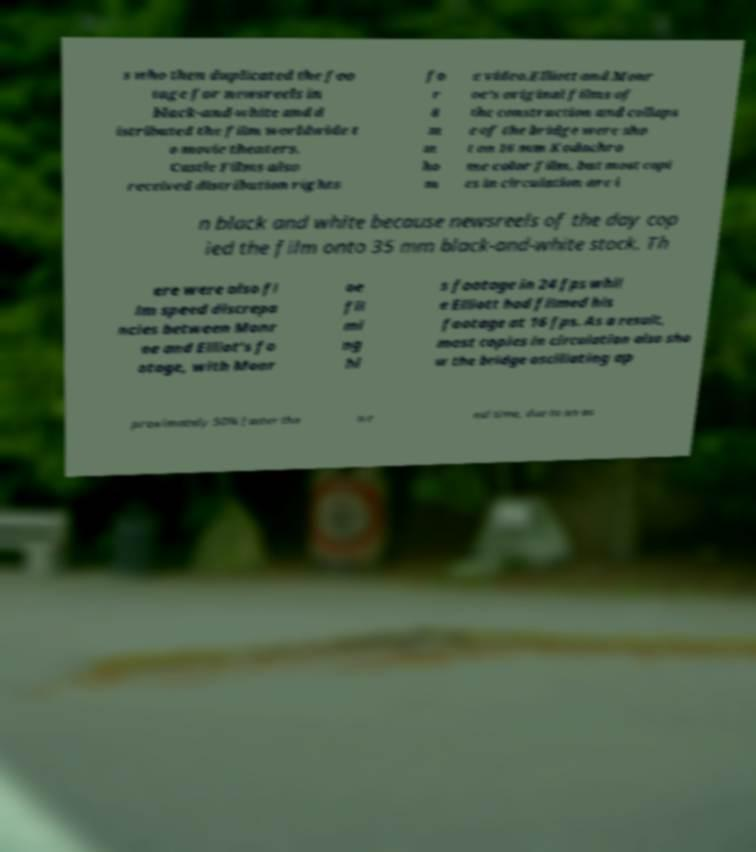Could you assist in decoding the text presented in this image and type it out clearly? s who then duplicated the foo tage for newsreels in black-and-white and d istributed the film worldwide t o movie theaters. Castle Films also received distribution rights fo r 8 m m ho m e video.Elliott and Monr oe's original films of the construction and collaps e of the bridge were sho t on 16 mm Kodachro me color film, but most copi es in circulation are i n black and white because newsreels of the day cop ied the film onto 35 mm black-and-white stock. Th ere were also fi lm speed discrepa ncies between Monr oe and Elliot's fo otage, with Monr oe fil mi ng hi s footage in 24 fps whil e Elliott had filmed his footage at 16 fps. As a result, most copies in circulation also sho w the bridge oscillating ap proximately 50% faster tha n r eal time, due to an as 